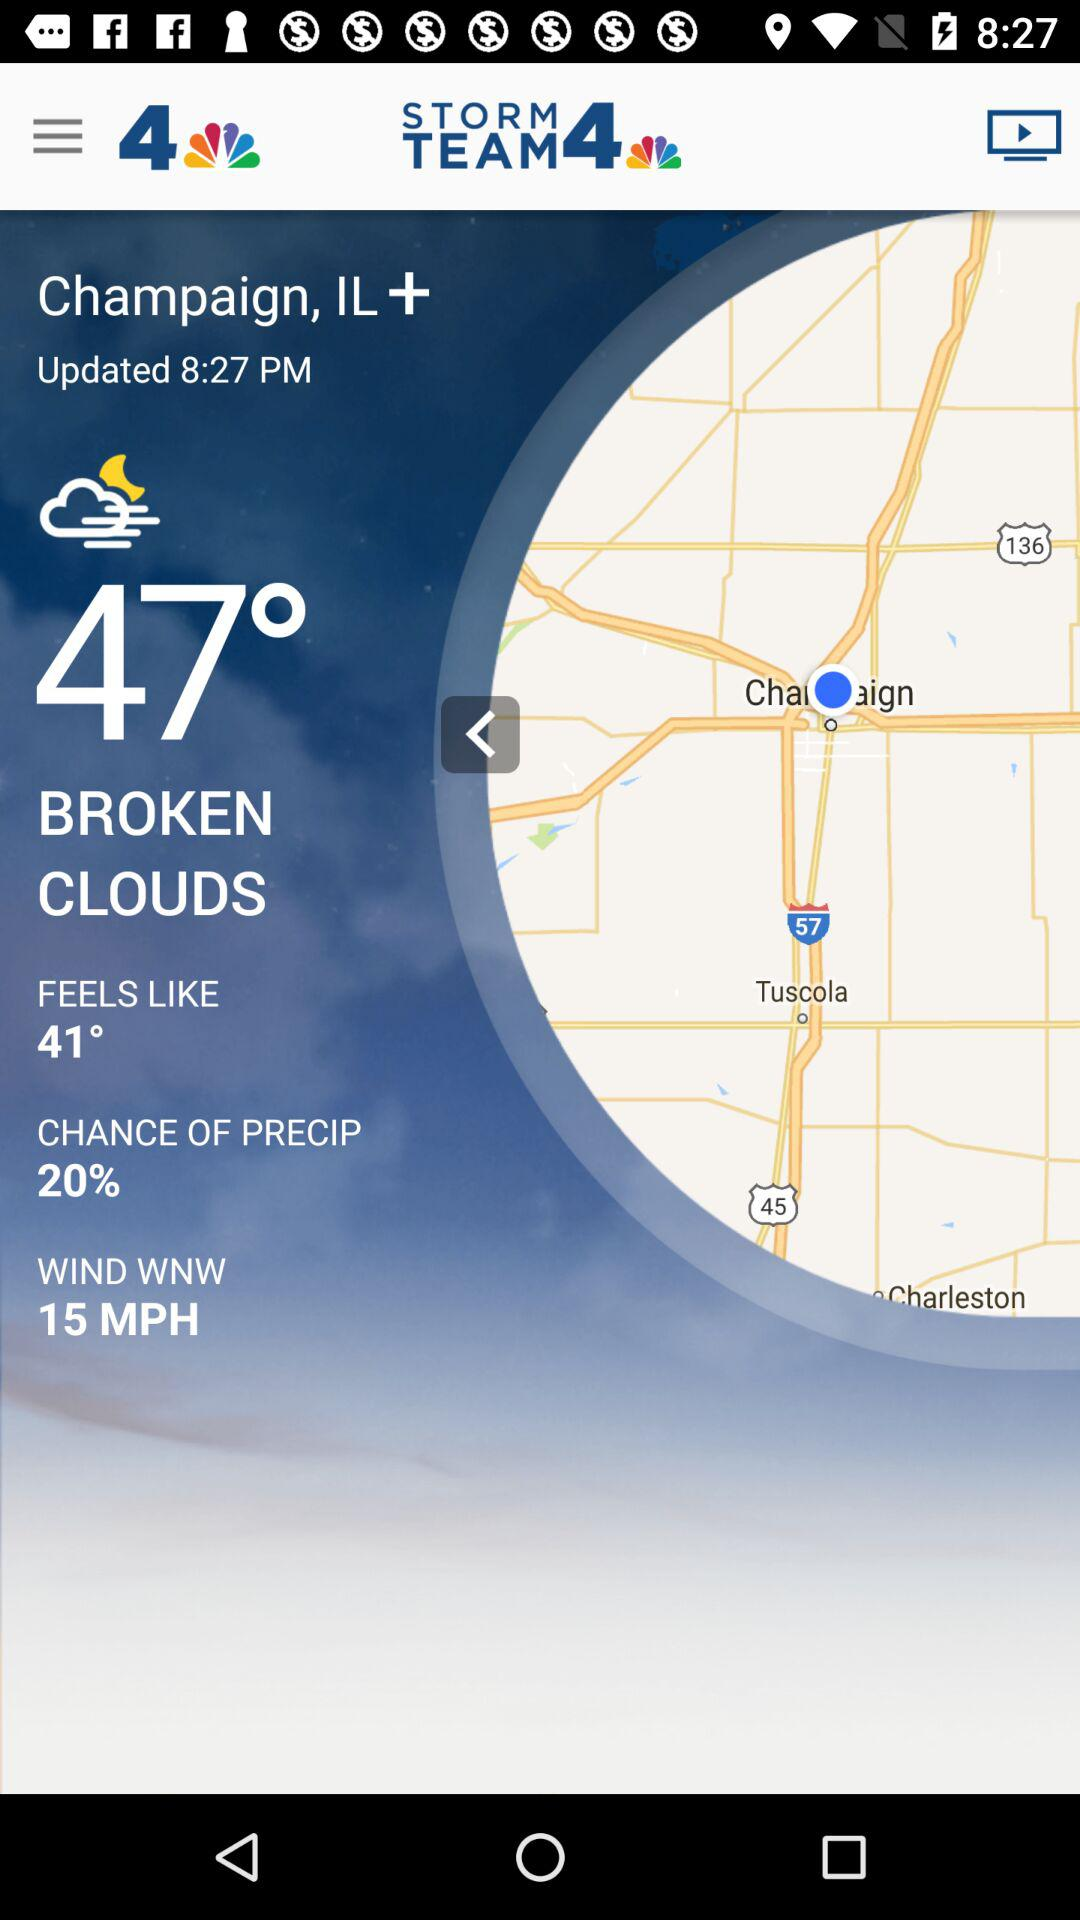How many degrees colder is the current temperature than the feels like temperature?
Answer the question using a single word or phrase. 6 